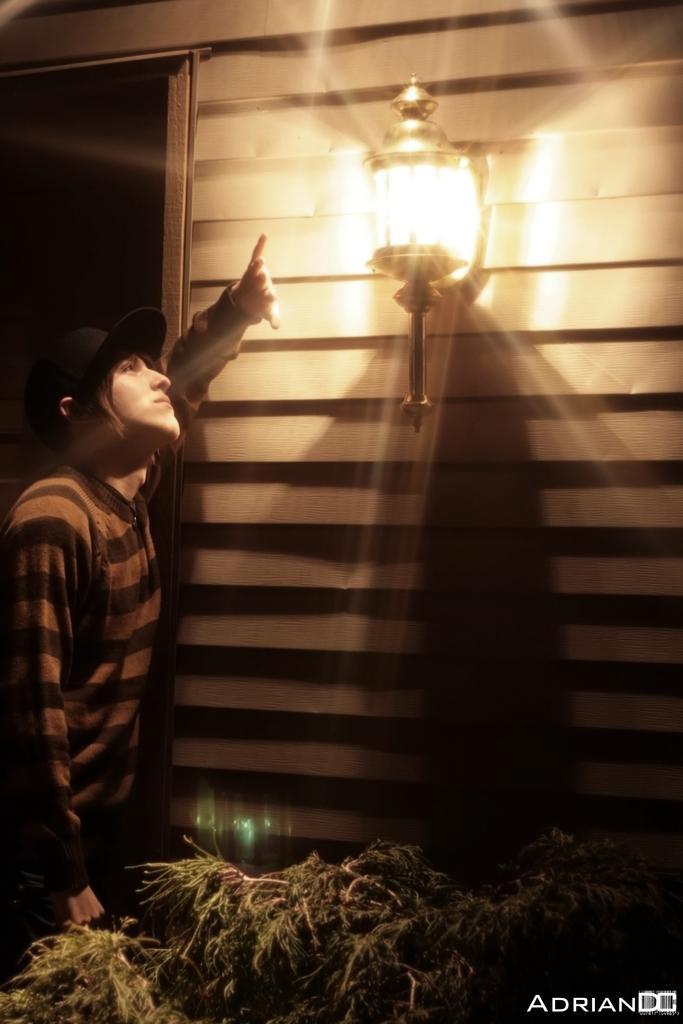Can you describe this image briefly? In this image I can see a person wearing t shirt, black hat is standing. I can see a tree and the building. I can see a lamp attached to the building. 